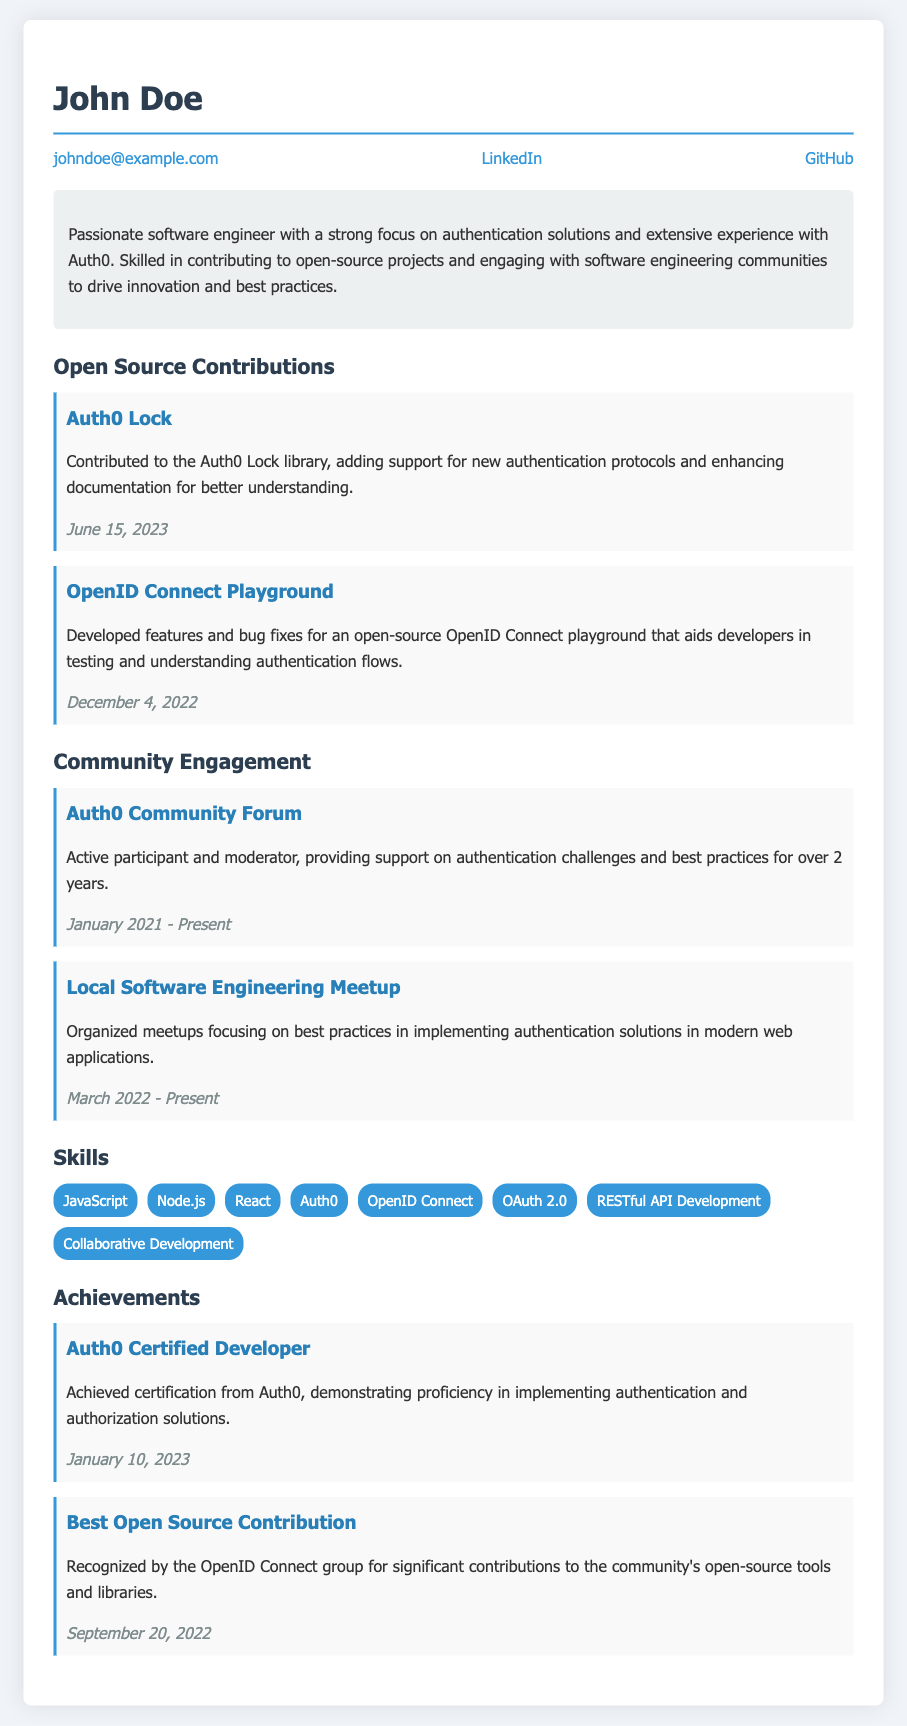What is the name of the resume's owner? The name of the resume's owner is mentioned at the top of the document.
Answer: John Doe When did John Doe contribute to the Auth0 Lock library? The contribution date for the Auth0 Lock library is clearly stated in the document.
Answer: June 15, 2023 What role does John Doe have in the Auth0 Community Forum? The document specifies John Doe's involvement in the community forum.
Answer: Moderator Which feature does the OpenID Connect Playground help developers test? The purpose of the OpenID Connect Playground is described in the contributions section.
Answer: Authentication flows How long has John Doe been active in the Auth0 Community Forum? The duration of John Doe's participation in the community forum is provided.
Answer: Over 2 years What certification does John Doe hold? The document outlines an achievement related to certification.
Answer: Auth0 Certified Developer How many skills are listed in the Skills section? The Skills section contains multiple skills which can be counted.
Answer: Eight What is the title of John Doe's achievement recognized by the OpenID Connect group? The document lists this title under achievements.
Answer: Best Open Source Contribution 